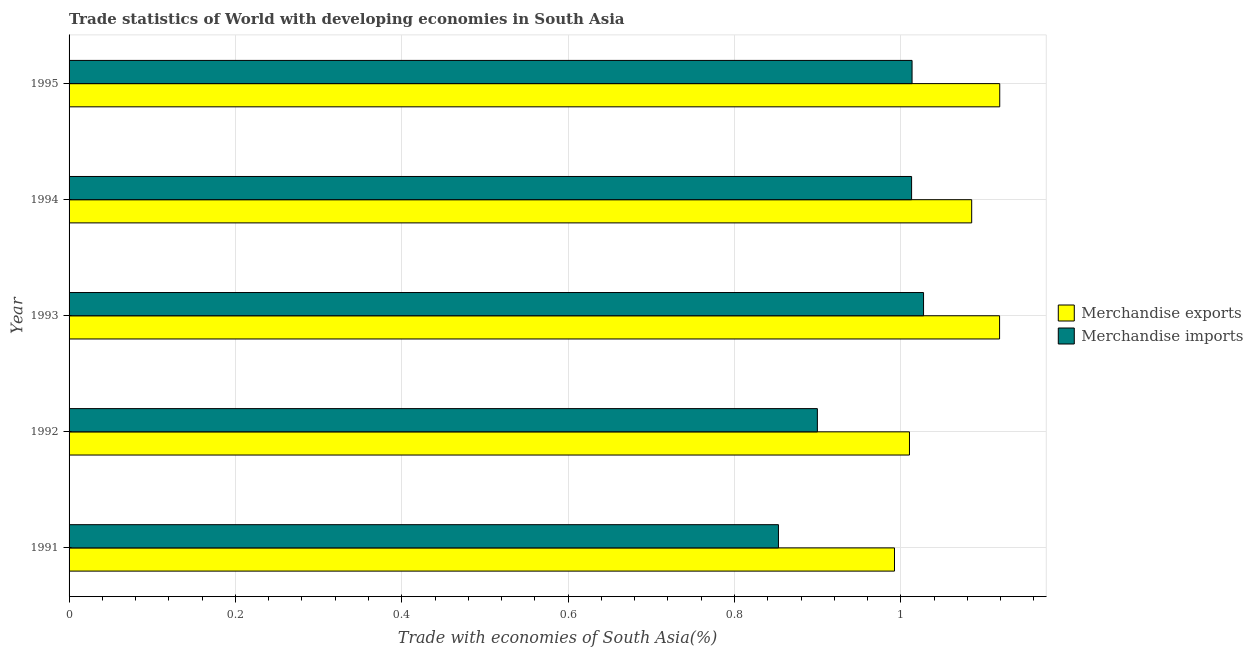Are the number of bars per tick equal to the number of legend labels?
Ensure brevity in your answer.  Yes. Are the number of bars on each tick of the Y-axis equal?
Provide a short and direct response. Yes. How many bars are there on the 5th tick from the bottom?
Offer a terse response. 2. In how many cases, is the number of bars for a given year not equal to the number of legend labels?
Give a very brief answer. 0. What is the merchandise imports in 1995?
Provide a short and direct response. 1.01. Across all years, what is the maximum merchandise imports?
Offer a very short reply. 1.03. Across all years, what is the minimum merchandise exports?
Offer a terse response. 0.99. In which year was the merchandise imports minimum?
Provide a short and direct response. 1991. What is the total merchandise imports in the graph?
Provide a short and direct response. 4.81. What is the difference between the merchandise imports in 1991 and that in 1993?
Provide a short and direct response. -0.17. What is the difference between the merchandise exports in 1992 and the merchandise imports in 1994?
Ensure brevity in your answer.  -0. What is the average merchandise exports per year?
Offer a terse response. 1.06. In the year 1991, what is the difference between the merchandise exports and merchandise imports?
Your answer should be very brief. 0.14. What is the ratio of the merchandise exports in 1994 to that in 1995?
Your response must be concise. 0.97. Is the difference between the merchandise imports in 1991 and 1995 greater than the difference between the merchandise exports in 1991 and 1995?
Keep it short and to the point. No. What is the difference between the highest and the second highest merchandise imports?
Offer a terse response. 0.01. What is the difference between the highest and the lowest merchandise exports?
Make the answer very short. 0.13. What does the 1st bar from the bottom in 1993 represents?
Your answer should be compact. Merchandise exports. What is the difference between two consecutive major ticks on the X-axis?
Offer a terse response. 0.2. Does the graph contain any zero values?
Your answer should be compact. No. Does the graph contain grids?
Your answer should be compact. Yes. How many legend labels are there?
Your answer should be very brief. 2. What is the title of the graph?
Offer a very short reply. Trade statistics of World with developing economies in South Asia. Does "Female labor force" appear as one of the legend labels in the graph?
Make the answer very short. No. What is the label or title of the X-axis?
Provide a succinct answer. Trade with economies of South Asia(%). What is the label or title of the Y-axis?
Provide a succinct answer. Year. What is the Trade with economies of South Asia(%) in Merchandise exports in 1991?
Offer a terse response. 0.99. What is the Trade with economies of South Asia(%) in Merchandise imports in 1991?
Keep it short and to the point. 0.85. What is the Trade with economies of South Asia(%) of Merchandise exports in 1992?
Your response must be concise. 1.01. What is the Trade with economies of South Asia(%) in Merchandise imports in 1992?
Ensure brevity in your answer.  0.9. What is the Trade with economies of South Asia(%) of Merchandise exports in 1993?
Provide a succinct answer. 1.12. What is the Trade with economies of South Asia(%) of Merchandise imports in 1993?
Offer a terse response. 1.03. What is the Trade with economies of South Asia(%) of Merchandise exports in 1994?
Keep it short and to the point. 1.09. What is the Trade with economies of South Asia(%) in Merchandise imports in 1994?
Provide a succinct answer. 1.01. What is the Trade with economies of South Asia(%) in Merchandise exports in 1995?
Give a very brief answer. 1.12. What is the Trade with economies of South Asia(%) of Merchandise imports in 1995?
Make the answer very short. 1.01. Across all years, what is the maximum Trade with economies of South Asia(%) in Merchandise exports?
Your answer should be compact. 1.12. Across all years, what is the maximum Trade with economies of South Asia(%) in Merchandise imports?
Make the answer very short. 1.03. Across all years, what is the minimum Trade with economies of South Asia(%) of Merchandise exports?
Offer a terse response. 0.99. Across all years, what is the minimum Trade with economies of South Asia(%) in Merchandise imports?
Keep it short and to the point. 0.85. What is the total Trade with economies of South Asia(%) of Merchandise exports in the graph?
Provide a short and direct response. 5.33. What is the total Trade with economies of South Asia(%) in Merchandise imports in the graph?
Provide a short and direct response. 4.81. What is the difference between the Trade with economies of South Asia(%) of Merchandise exports in 1991 and that in 1992?
Your response must be concise. -0.02. What is the difference between the Trade with economies of South Asia(%) of Merchandise imports in 1991 and that in 1992?
Give a very brief answer. -0.05. What is the difference between the Trade with economies of South Asia(%) of Merchandise exports in 1991 and that in 1993?
Give a very brief answer. -0.13. What is the difference between the Trade with economies of South Asia(%) in Merchandise imports in 1991 and that in 1993?
Offer a terse response. -0.17. What is the difference between the Trade with economies of South Asia(%) in Merchandise exports in 1991 and that in 1994?
Ensure brevity in your answer.  -0.09. What is the difference between the Trade with economies of South Asia(%) of Merchandise imports in 1991 and that in 1994?
Keep it short and to the point. -0.16. What is the difference between the Trade with economies of South Asia(%) in Merchandise exports in 1991 and that in 1995?
Make the answer very short. -0.13. What is the difference between the Trade with economies of South Asia(%) in Merchandise imports in 1991 and that in 1995?
Provide a succinct answer. -0.16. What is the difference between the Trade with economies of South Asia(%) of Merchandise exports in 1992 and that in 1993?
Your answer should be very brief. -0.11. What is the difference between the Trade with economies of South Asia(%) of Merchandise imports in 1992 and that in 1993?
Provide a short and direct response. -0.13. What is the difference between the Trade with economies of South Asia(%) of Merchandise exports in 1992 and that in 1994?
Ensure brevity in your answer.  -0.07. What is the difference between the Trade with economies of South Asia(%) in Merchandise imports in 1992 and that in 1994?
Your answer should be very brief. -0.11. What is the difference between the Trade with economies of South Asia(%) of Merchandise exports in 1992 and that in 1995?
Keep it short and to the point. -0.11. What is the difference between the Trade with economies of South Asia(%) of Merchandise imports in 1992 and that in 1995?
Keep it short and to the point. -0.11. What is the difference between the Trade with economies of South Asia(%) in Merchandise exports in 1993 and that in 1994?
Offer a very short reply. 0.03. What is the difference between the Trade with economies of South Asia(%) of Merchandise imports in 1993 and that in 1994?
Ensure brevity in your answer.  0.01. What is the difference between the Trade with economies of South Asia(%) in Merchandise exports in 1993 and that in 1995?
Give a very brief answer. -0. What is the difference between the Trade with economies of South Asia(%) of Merchandise imports in 1993 and that in 1995?
Your response must be concise. 0.01. What is the difference between the Trade with economies of South Asia(%) in Merchandise exports in 1994 and that in 1995?
Ensure brevity in your answer.  -0.03. What is the difference between the Trade with economies of South Asia(%) in Merchandise imports in 1994 and that in 1995?
Your response must be concise. -0. What is the difference between the Trade with economies of South Asia(%) of Merchandise exports in 1991 and the Trade with economies of South Asia(%) of Merchandise imports in 1992?
Ensure brevity in your answer.  0.09. What is the difference between the Trade with economies of South Asia(%) of Merchandise exports in 1991 and the Trade with economies of South Asia(%) of Merchandise imports in 1993?
Keep it short and to the point. -0.03. What is the difference between the Trade with economies of South Asia(%) of Merchandise exports in 1991 and the Trade with economies of South Asia(%) of Merchandise imports in 1994?
Make the answer very short. -0.02. What is the difference between the Trade with economies of South Asia(%) of Merchandise exports in 1991 and the Trade with economies of South Asia(%) of Merchandise imports in 1995?
Ensure brevity in your answer.  -0.02. What is the difference between the Trade with economies of South Asia(%) in Merchandise exports in 1992 and the Trade with economies of South Asia(%) in Merchandise imports in 1993?
Give a very brief answer. -0.02. What is the difference between the Trade with economies of South Asia(%) of Merchandise exports in 1992 and the Trade with economies of South Asia(%) of Merchandise imports in 1994?
Offer a very short reply. -0. What is the difference between the Trade with economies of South Asia(%) in Merchandise exports in 1992 and the Trade with economies of South Asia(%) in Merchandise imports in 1995?
Offer a terse response. -0. What is the difference between the Trade with economies of South Asia(%) in Merchandise exports in 1993 and the Trade with economies of South Asia(%) in Merchandise imports in 1994?
Give a very brief answer. 0.11. What is the difference between the Trade with economies of South Asia(%) of Merchandise exports in 1993 and the Trade with economies of South Asia(%) of Merchandise imports in 1995?
Offer a terse response. 0.11. What is the difference between the Trade with economies of South Asia(%) in Merchandise exports in 1994 and the Trade with economies of South Asia(%) in Merchandise imports in 1995?
Your answer should be compact. 0.07. What is the average Trade with economies of South Asia(%) in Merchandise exports per year?
Ensure brevity in your answer.  1.07. What is the average Trade with economies of South Asia(%) in Merchandise imports per year?
Give a very brief answer. 0.96. In the year 1991, what is the difference between the Trade with economies of South Asia(%) of Merchandise exports and Trade with economies of South Asia(%) of Merchandise imports?
Your answer should be very brief. 0.14. In the year 1992, what is the difference between the Trade with economies of South Asia(%) of Merchandise exports and Trade with economies of South Asia(%) of Merchandise imports?
Make the answer very short. 0.11. In the year 1993, what is the difference between the Trade with economies of South Asia(%) in Merchandise exports and Trade with economies of South Asia(%) in Merchandise imports?
Offer a terse response. 0.09. In the year 1994, what is the difference between the Trade with economies of South Asia(%) in Merchandise exports and Trade with economies of South Asia(%) in Merchandise imports?
Provide a short and direct response. 0.07. In the year 1995, what is the difference between the Trade with economies of South Asia(%) of Merchandise exports and Trade with economies of South Asia(%) of Merchandise imports?
Make the answer very short. 0.11. What is the ratio of the Trade with economies of South Asia(%) of Merchandise exports in 1991 to that in 1992?
Your answer should be compact. 0.98. What is the ratio of the Trade with economies of South Asia(%) in Merchandise imports in 1991 to that in 1992?
Offer a terse response. 0.95. What is the ratio of the Trade with economies of South Asia(%) of Merchandise exports in 1991 to that in 1993?
Make the answer very short. 0.89. What is the ratio of the Trade with economies of South Asia(%) of Merchandise imports in 1991 to that in 1993?
Make the answer very short. 0.83. What is the ratio of the Trade with economies of South Asia(%) in Merchandise exports in 1991 to that in 1994?
Give a very brief answer. 0.91. What is the ratio of the Trade with economies of South Asia(%) of Merchandise imports in 1991 to that in 1994?
Your answer should be very brief. 0.84. What is the ratio of the Trade with economies of South Asia(%) in Merchandise exports in 1991 to that in 1995?
Your answer should be very brief. 0.89. What is the ratio of the Trade with economies of South Asia(%) of Merchandise imports in 1991 to that in 1995?
Your answer should be compact. 0.84. What is the ratio of the Trade with economies of South Asia(%) of Merchandise exports in 1992 to that in 1993?
Your response must be concise. 0.9. What is the ratio of the Trade with economies of South Asia(%) in Merchandise imports in 1992 to that in 1993?
Offer a very short reply. 0.88. What is the ratio of the Trade with economies of South Asia(%) of Merchandise exports in 1992 to that in 1994?
Offer a very short reply. 0.93. What is the ratio of the Trade with economies of South Asia(%) in Merchandise imports in 1992 to that in 1994?
Provide a succinct answer. 0.89. What is the ratio of the Trade with economies of South Asia(%) in Merchandise exports in 1992 to that in 1995?
Give a very brief answer. 0.9. What is the ratio of the Trade with economies of South Asia(%) of Merchandise imports in 1992 to that in 1995?
Provide a short and direct response. 0.89. What is the ratio of the Trade with economies of South Asia(%) of Merchandise exports in 1993 to that in 1994?
Your answer should be very brief. 1.03. What is the ratio of the Trade with economies of South Asia(%) of Merchandise imports in 1993 to that in 1994?
Offer a terse response. 1.01. What is the ratio of the Trade with economies of South Asia(%) of Merchandise imports in 1993 to that in 1995?
Give a very brief answer. 1.01. What is the ratio of the Trade with economies of South Asia(%) in Merchandise exports in 1994 to that in 1995?
Make the answer very short. 0.97. What is the ratio of the Trade with economies of South Asia(%) of Merchandise imports in 1994 to that in 1995?
Make the answer very short. 1. What is the difference between the highest and the second highest Trade with economies of South Asia(%) of Merchandise exports?
Provide a short and direct response. 0. What is the difference between the highest and the second highest Trade with economies of South Asia(%) of Merchandise imports?
Ensure brevity in your answer.  0.01. What is the difference between the highest and the lowest Trade with economies of South Asia(%) in Merchandise exports?
Offer a terse response. 0.13. What is the difference between the highest and the lowest Trade with economies of South Asia(%) of Merchandise imports?
Your answer should be compact. 0.17. 